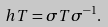<formula> <loc_0><loc_0><loc_500><loc_500>\ h T = \sigma T \sigma ^ { - 1 } .</formula> 